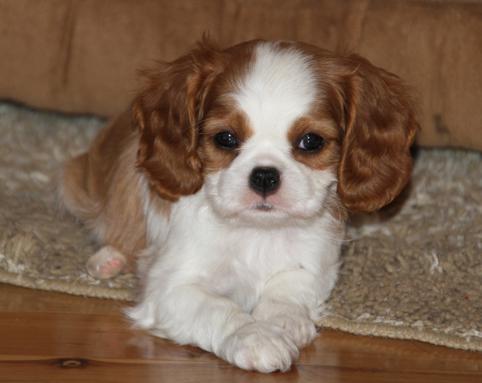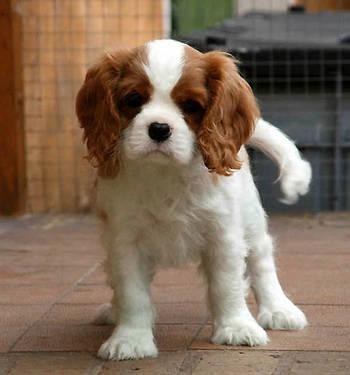The first image is the image on the left, the second image is the image on the right. Analyze the images presented: Is the assertion "An image shows a puppy on a tile floor." valid? Answer yes or no. Yes. 